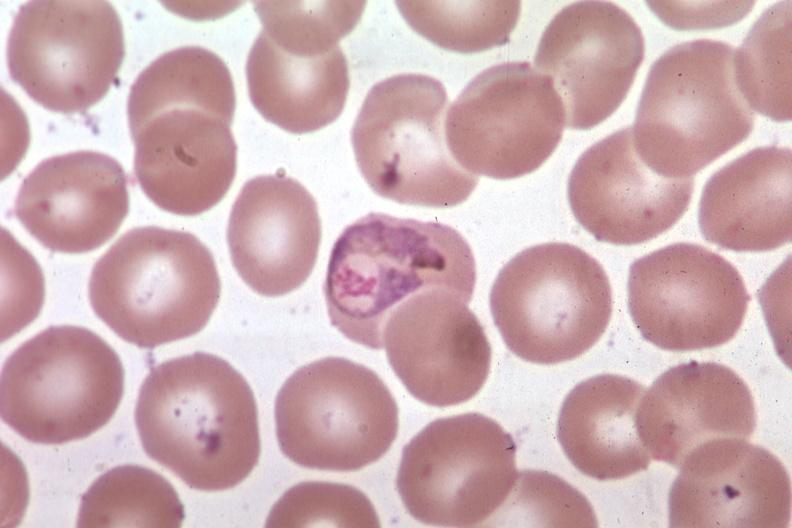s cardiovascular present?
Answer the question using a single word or phrase. No 